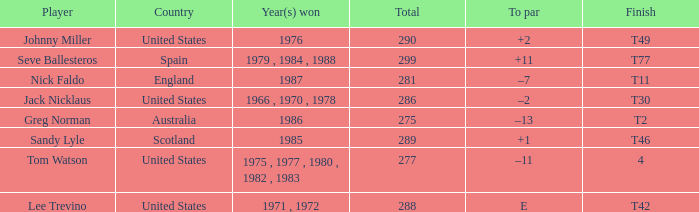In which country did a finish of t49 occur? United States. 